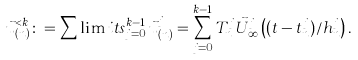Convert formula to latex. <formula><loc_0><loc_0><loc_500><loc_500>\vec { u } _ { ( n ) } ^ { < k } \colon = \sum \lim i t s _ { j = 0 } ^ { k - 1 } \vec { u } _ { ( n ) } ^ { j } = \sum _ { j = 0 } ^ { k - 1 } T _ { n } ^ { j } \vec { U } _ { \infty } ^ { j } \left ( ( t - t _ { n } ^ { j } ) / h _ { n } ^ { j } \right ) .</formula> 